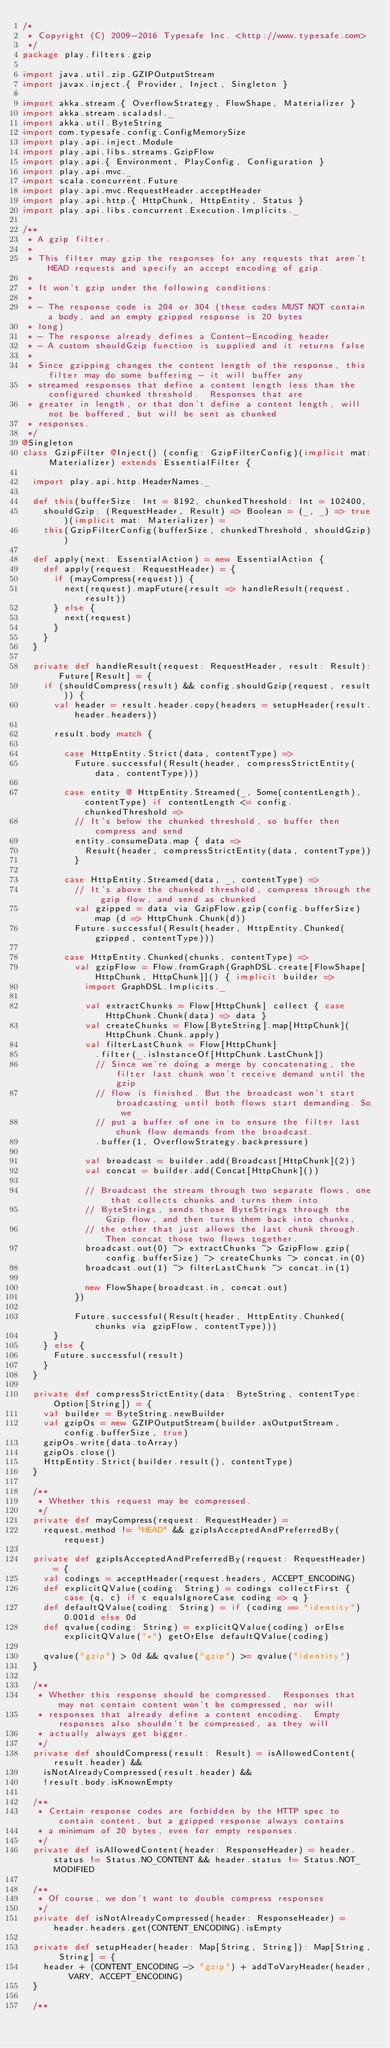Convert code to text. <code><loc_0><loc_0><loc_500><loc_500><_Scala_>/*
 * Copyright (C) 2009-2016 Typesafe Inc. <http://www.typesafe.com>
 */
package play.filters.gzip

import java.util.zip.GZIPOutputStream
import javax.inject.{ Provider, Inject, Singleton }

import akka.stream.{ OverflowStrategy, FlowShape, Materializer }
import akka.stream.scaladsl._
import akka.util.ByteString
import com.typesafe.config.ConfigMemorySize
import play.api.inject.Module
import play.api.libs.streams.GzipFlow
import play.api.{ Environment, PlayConfig, Configuration }
import play.api.mvc._
import scala.concurrent.Future
import play.api.mvc.RequestHeader.acceptHeader
import play.api.http.{ HttpChunk, HttpEntity, Status }
import play.api.libs.concurrent.Execution.Implicits._

/**
 * A gzip filter.
 *
 * This filter may gzip the responses for any requests that aren't HEAD requests and specify an accept encoding of gzip.
 *
 * It won't gzip under the following conditions:
 *
 * - The response code is 204 or 304 (these codes MUST NOT contain a body, and an empty gzipped response is 20 bytes
 * long)
 * - The response already defines a Content-Encoding header
 * - A custom shouldGzip function is supplied and it returns false
 *
 * Since gzipping changes the content length of the response, this filter may do some buffering - it will buffer any
 * streamed responses that define a content length less than the configured chunked threshold.  Responses that are
 * greater in length, or that don't define a content length, will not be buffered, but will be sent as chunked
 * responses.
 */
@Singleton
class GzipFilter @Inject() (config: GzipFilterConfig)(implicit mat: Materializer) extends EssentialFilter {

  import play.api.http.HeaderNames._

  def this(bufferSize: Int = 8192, chunkedThreshold: Int = 102400,
    shouldGzip: (RequestHeader, Result) => Boolean = (_, _) => true)(implicit mat: Materializer) =
    this(GzipFilterConfig(bufferSize, chunkedThreshold, shouldGzip))

  def apply(next: EssentialAction) = new EssentialAction {
    def apply(request: RequestHeader) = {
      if (mayCompress(request)) {
        next(request).mapFuture(result => handleResult(request, result))
      } else {
        next(request)
      }
    }
  }

  private def handleResult(request: RequestHeader, result: Result): Future[Result] = {
    if (shouldCompress(result) && config.shouldGzip(request, result)) {
      val header = result.header.copy(headers = setupHeader(result.header.headers))

      result.body match {

        case HttpEntity.Strict(data, contentType) =>
          Future.successful(Result(header, compressStrictEntity(data, contentType)))

        case entity @ HttpEntity.Streamed(_, Some(contentLength), contentType) if contentLength <= config.chunkedThreshold =>
          // It's below the chunked threshold, so buffer then compress and send
          entity.consumeData.map { data =>
            Result(header, compressStrictEntity(data, contentType))
          }

        case HttpEntity.Streamed(data, _, contentType) =>
          // It's above the chunked threshold, compress through the gzip flow, and send as chunked
          val gzipped = data via GzipFlow.gzip(config.bufferSize) map (d => HttpChunk.Chunk(d))
          Future.successful(Result(header, HttpEntity.Chunked(gzipped, contentType)))

        case HttpEntity.Chunked(chunks, contentType) =>
          val gzipFlow = Flow.fromGraph(GraphDSL.create[FlowShape[HttpChunk, HttpChunk]]() { implicit builder =>
            import GraphDSL.Implicits._

            val extractChunks = Flow[HttpChunk] collect { case HttpChunk.Chunk(data) => data }
            val createChunks = Flow[ByteString].map[HttpChunk](HttpChunk.Chunk.apply)
            val filterLastChunk = Flow[HttpChunk]
              .filter(_.isInstanceOf[HttpChunk.LastChunk])
              // Since we're doing a merge by concatenating, the filter last chunk won't receive demand until the gzip
              // flow is finished. But the broadcast won't start broadcasting until both flows start demanding. So we
              // put a buffer of one in to ensure the filter last chunk flow demands from the broadcast.
              .buffer(1, OverflowStrategy.backpressure)

            val broadcast = builder.add(Broadcast[HttpChunk](2))
            val concat = builder.add(Concat[HttpChunk]())

            // Broadcast the stream through two separate flows, one that collects chunks and turns them into
            // ByteStrings, sends those ByteStrings through the Gzip flow, and then turns them back into chunks,
            // the other that just allows the last chunk through. Then concat those two flows together.
            broadcast.out(0) ~> extractChunks ~> GzipFlow.gzip(config.bufferSize) ~> createChunks ~> concat.in(0)
            broadcast.out(1) ~> filterLastChunk ~> concat.in(1)

            new FlowShape(broadcast.in, concat.out)
          })

          Future.successful(Result(header, HttpEntity.Chunked(chunks via gzipFlow, contentType)))
      }
    } else {
      Future.successful(result)
    }
  }

  private def compressStrictEntity(data: ByteString, contentType: Option[String]) = {
    val builder = ByteString.newBuilder
    val gzipOs = new GZIPOutputStream(builder.asOutputStream, config.bufferSize, true)
    gzipOs.write(data.toArray)
    gzipOs.close()
    HttpEntity.Strict(builder.result(), contentType)
  }

  /**
   * Whether this request may be compressed.
   */
  private def mayCompress(request: RequestHeader) =
    request.method != "HEAD" && gzipIsAcceptedAndPreferredBy(request)

  private def gzipIsAcceptedAndPreferredBy(request: RequestHeader) = {
    val codings = acceptHeader(request.headers, ACCEPT_ENCODING)
    def explicitQValue(coding: String) = codings collectFirst { case (q, c) if c equalsIgnoreCase coding => q }
    def defaultQValue(coding: String) = if (coding == "identity") 0.001d else 0d
    def qvalue(coding: String) = explicitQValue(coding) orElse explicitQValue("*") getOrElse defaultQValue(coding)

    qvalue("gzip") > 0d && qvalue("gzip") >= qvalue("identity")
  }

  /**
   * Whether this response should be compressed.  Responses that may not contain content won't be compressed, nor will
   * responses that already define a content encoding.  Empty responses also shouldn't be compressed, as they will
   * actually always get bigger.
   */
  private def shouldCompress(result: Result) = isAllowedContent(result.header) &&
    isNotAlreadyCompressed(result.header) &&
    !result.body.isKnownEmpty

  /**
   * Certain response codes are forbidden by the HTTP spec to contain content, but a gzipped response always contains
   * a minimum of 20 bytes, even for empty responses.
   */
  private def isAllowedContent(header: ResponseHeader) = header.status != Status.NO_CONTENT && header.status != Status.NOT_MODIFIED

  /**
   * Of course, we don't want to double compress responses
   */
  private def isNotAlreadyCompressed(header: ResponseHeader) = header.headers.get(CONTENT_ENCODING).isEmpty

  private def setupHeader(header: Map[String, String]): Map[String, String] = {
    header + (CONTENT_ENCODING -> "gzip") + addToVaryHeader(header, VARY, ACCEPT_ENCODING)
  }

  /**</code> 